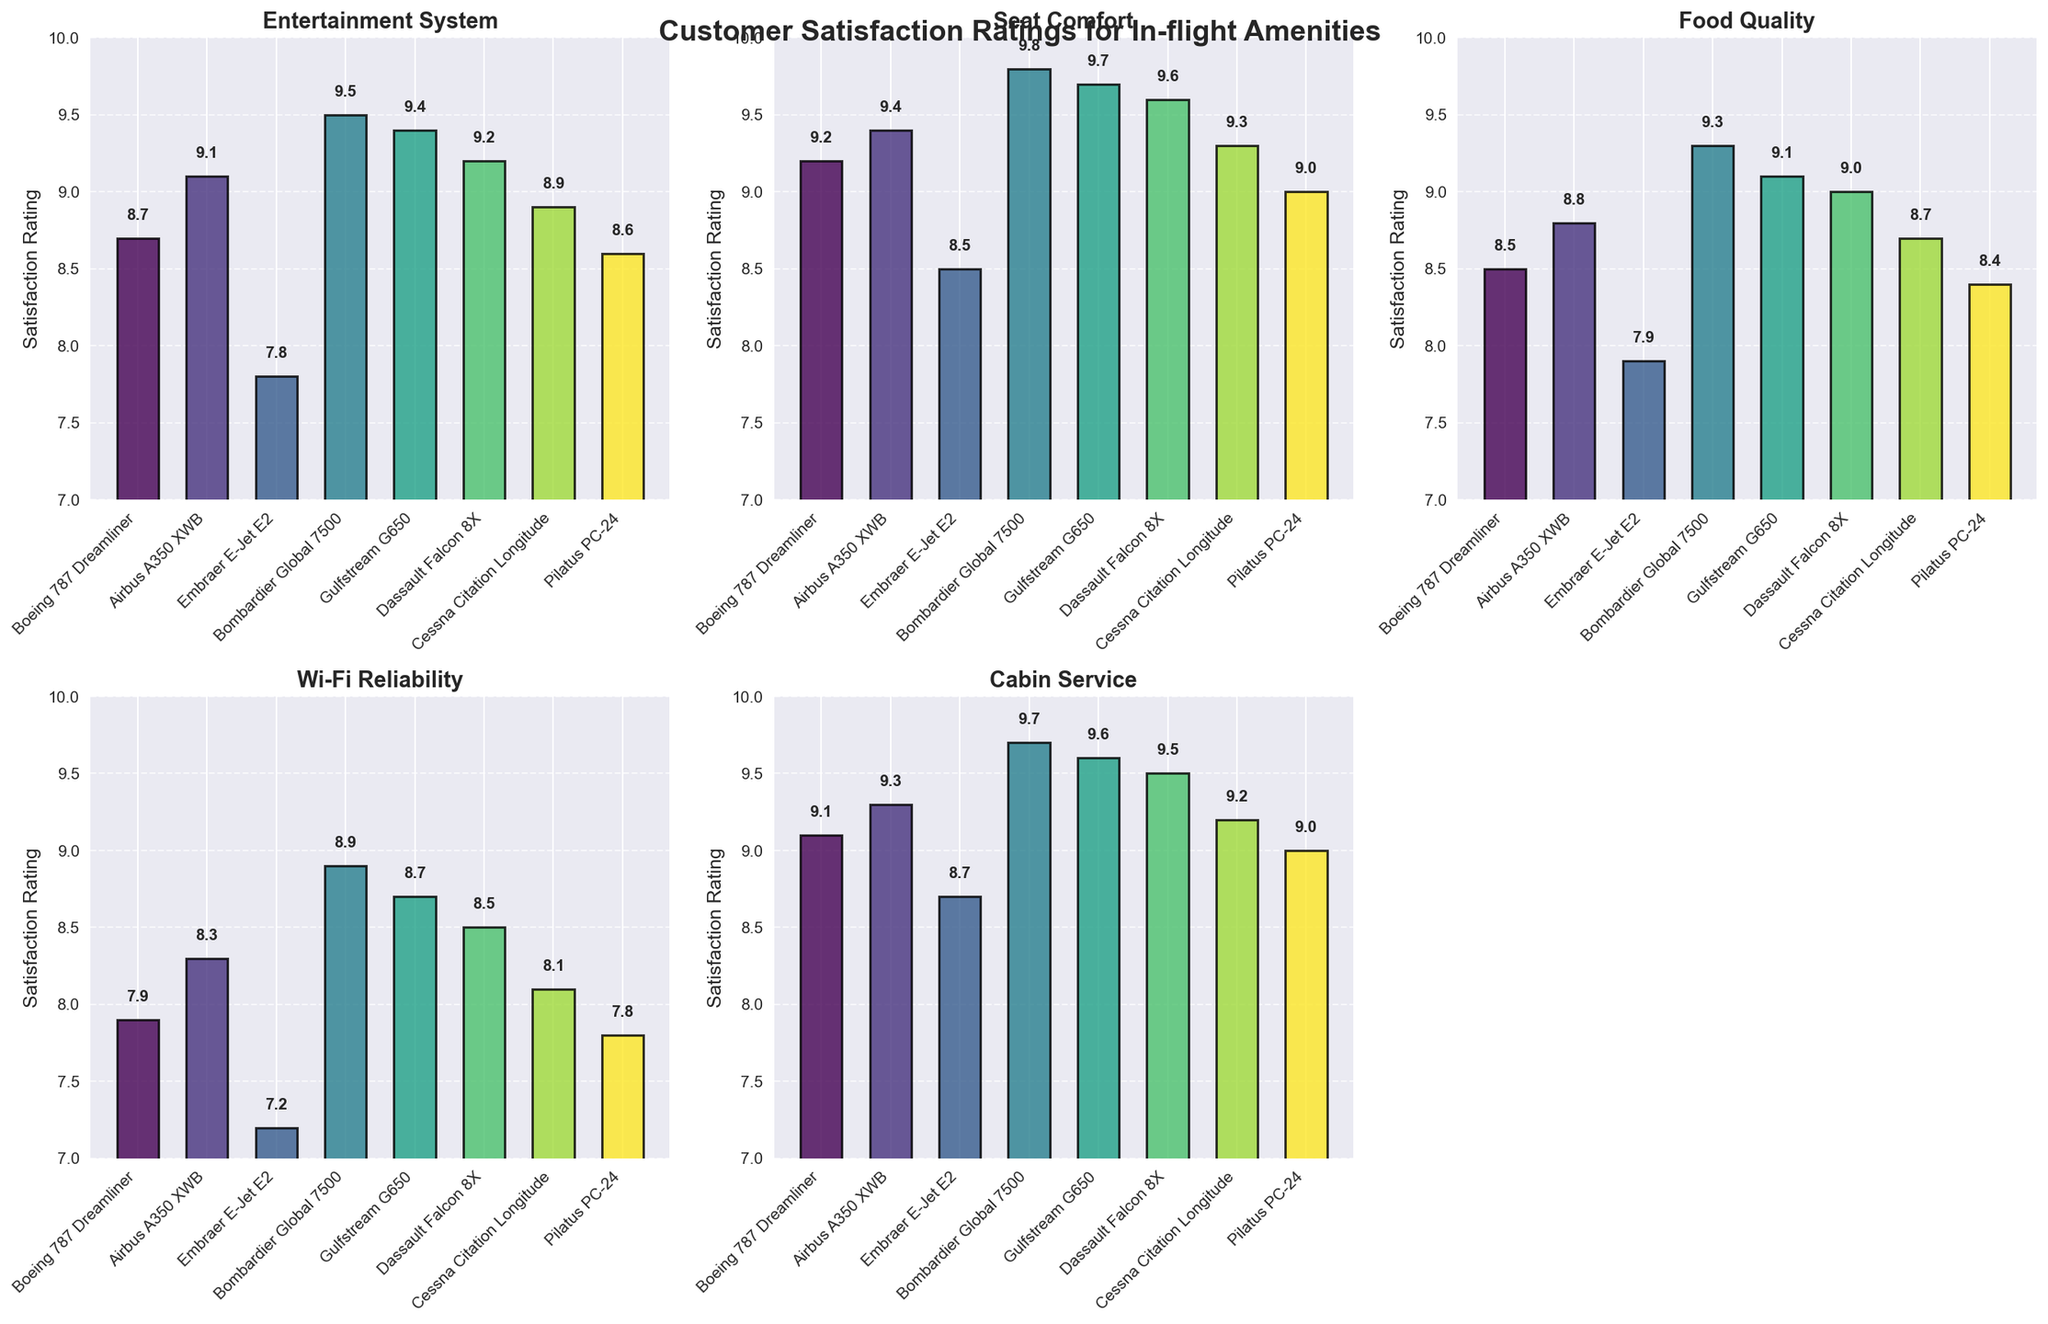What is the title of the figure? The title is usually placed at the top of the figure. In this case, it is mentioned in the code generating the figure.
Answer: Customer Satisfaction Ratings for In-flight Amenities Which aircraft model has the highest rating for Entertainment System? To find the highest rating, compare the bars in the Entertainment System subplot. The highest bar corresponds to the aircraft model Bombardier Global 7500 with a rating of 9.5.
Answer: Bombardier Global 7500 What is the range of satisfaction ratings for Seat Comfort? The lowest rating is 8.5 (Embraer E-Jet E2) and the highest is 9.8 (Bombardier Global 7500). The range is the difference between the highest and lowest ratings.
Answer: 1.3 Which amenity has the most consistent (smallest range) customer satisfaction ratings across all models? Calculate the range for each amenity: Entertainment System (7.8 to 9.5), Seat Comfort (8.5 to 9.8), Food Quality (7.9 to 9.3), Wi-Fi Reliability (7.2 to 8.9), Cabin Service (8.7 to 9.7). Wi-Fi Reliability has the smallest range (1.7).
Answer: Wi-Fi Reliability Which aircraft model has the lowest rating for Wi-Fi Reliability? Look at the Wi-Fi Reliability subplot and identify the bar with the lowest height. This corresponds to Embraer E-Jet E2 with a rating of 7.2.
Answer: Embraer E-Jet E2 What's the average rating for Food Quality across all aircraft models? Sum up all the ratings for Food Quality: 8.5 + 8.8 + 7.9 + 9.3 + 9.1 + 9.0 + 8.7 + 8.4 = 69.7. There are 8 models, so average = 69.7 / 8 = 8.71.
Answer: 8.71 How do the customer satisfaction ratings for Seat Comfort compare between Airbus A350 XWB and Dassault Falcon 8X? The ratings for Seat Comfort are 9.4 for Airbus A350 XWB and 9.6 for Dassault Falcon 8X. Dassault Falcon 8X has a higher rating by 0.2.
Answer: Dassault Falcon 8X has higher rating by 0.2 Which two aircraft models have the highest average satisfaction ratings across all amenities? Calculate the average rating for each model: Boeing 787 Dreamliner (8.68), Airbus A350 XWB (8.98), Embraer E-Jet E2 (8.02), Bombardier Global 7500 (9.44), Gulfstream G650 (9.3), Dassault Falcon 8X (9.16), Cessna Citation Longitude (8.84), Pilatus PC-24 (8.56). The two highest averages are Bombardier Global 7500 (9.44) and Gulfstream G650 (9.3).
Answer: Bombardier Global 7500 and Gulfstream G650 